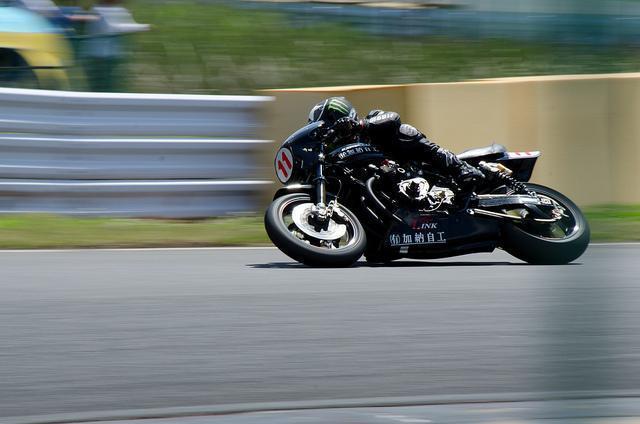How many people are there?
Give a very brief answer. 2. 